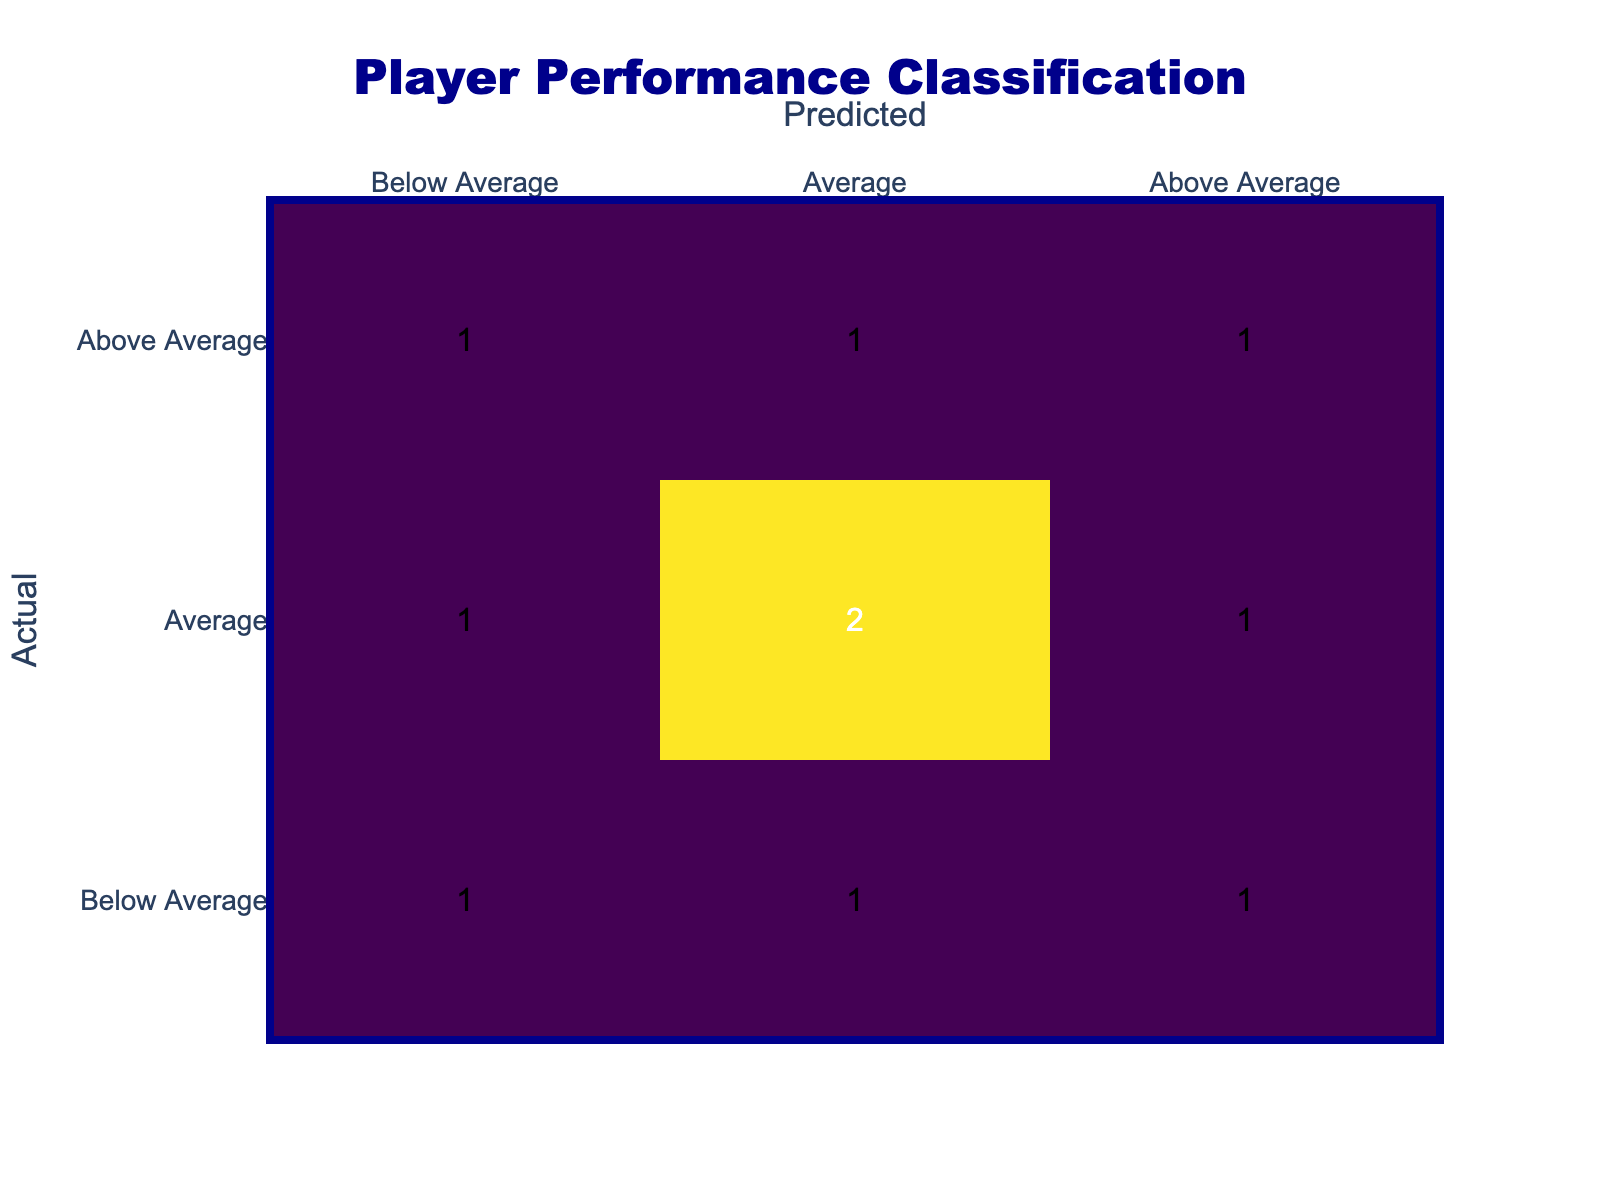What is the total number of players classified as "Below Average"? From the confusion matrix, we can see that there are two players classified as "Below Average" for both their actual and predicted performance ratings (Jamie Peters and Noah Hils). When we check the players classified as "Below Average" in the actual performance row, the total is 3 (Jamie Peters, Noah Hils, and Daan Bloem).
Answer: 3 Which player had an actual performance rating above the expected but was predicted to perform below average? Looking at the table, Rick Smits is the only player where the actual performance rating (7.0) exceeds the expected performance rating (5.0), while being predicted as "Below Average."
Answer: Rick Smits How many players were correctly classified as "Average" in both actual and predicted performance? Referring to the table, we find that Maxime Bell and Elena Mendez both fall under the "Average" category for both actual and predicted performances, confirming two players were correctly classified.
Answer: 2 Is there any player predicted to have an "Above Average" performance but was classified as "Below Average" in actual performance? Examining the table, Sophie van Dijk is predicted as "Above Average," but her actual performance is classified as "Below Average." This confirms the answer is yes.
Answer: Yes What is the difference between the number of players predicted as "Above Average" and "Below Average"? In the predicted performance, there are four players classified as "Above Average" and three as "Below Average." The difference calculates as 4 - 3 = 1, indicating one more player was predicted "Above Average" than "Below Average."
Answer: 1 How many players had an expected performance rating of 6.0 or higher and were predicted to be "Average"? Looking through the table, two players, Maxime Bell (6.5) and Elena Mendez (6.5), meet the criterion of having an expected rating of 6.0 or higher while being predicted as "Average." Therefore, the total is 2 players.
Answer: 2 Which position has the highest number of players classified as "Average"? By checking the data, the Midfielder position has Maxime Bell, who is "Average" in predicted performance. From the entire dataset, we find a tie, with two Midfielders (Maxime Bell and Sophia van Dijk) classified as "Average."
Answer: Midfielder 